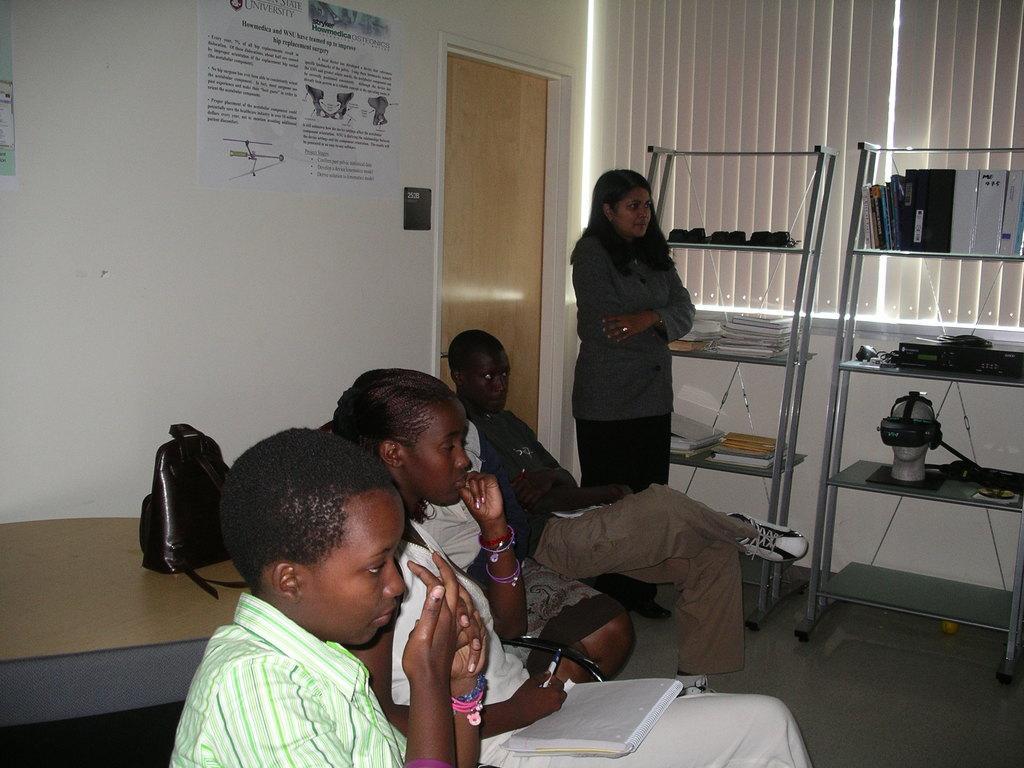How would you summarize this image in a sentence or two? In this image I can see few persons sitting on the chair. I can see a woman standing. In the background there is a door. There are two racks. I can see a big window. 